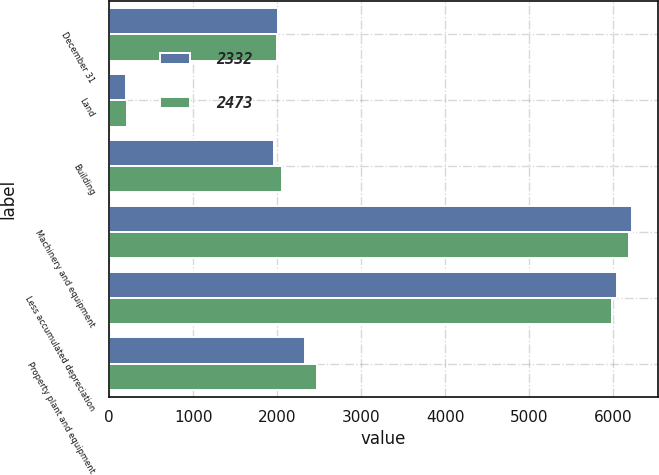Convert chart. <chart><loc_0><loc_0><loc_500><loc_500><stacked_bar_chart><ecel><fcel>December 31<fcel>Land<fcel>Building<fcel>Machinery and equipment<fcel>Less accumulated depreciation<fcel>Property plant and equipment<nl><fcel>2332<fcel>2004<fcel>200<fcel>1959<fcel>6222<fcel>6049<fcel>2332<nl><fcel>2473<fcel>2003<fcel>212<fcel>2061<fcel>6189<fcel>5989<fcel>2473<nl></chart> 